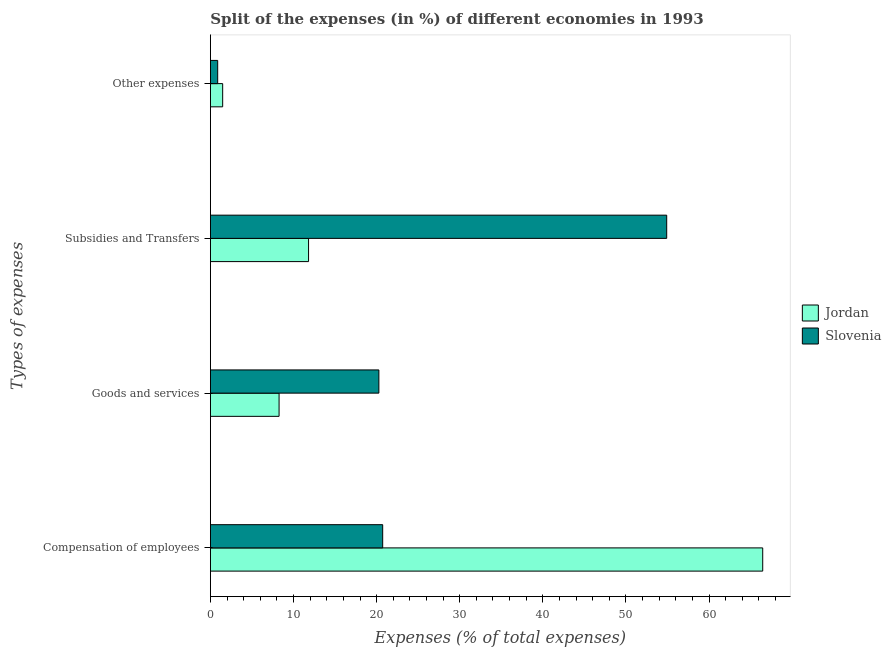Are the number of bars per tick equal to the number of legend labels?
Offer a very short reply. Yes. Are the number of bars on each tick of the Y-axis equal?
Provide a succinct answer. Yes. How many bars are there on the 3rd tick from the bottom?
Keep it short and to the point. 2. What is the label of the 3rd group of bars from the top?
Provide a succinct answer. Goods and services. What is the percentage of amount spent on other expenses in Jordan?
Your response must be concise. 1.48. Across all countries, what is the maximum percentage of amount spent on compensation of employees?
Your response must be concise. 66.45. Across all countries, what is the minimum percentage of amount spent on other expenses?
Provide a succinct answer. 0.88. In which country was the percentage of amount spent on subsidies maximum?
Ensure brevity in your answer.  Slovenia. In which country was the percentage of amount spent on compensation of employees minimum?
Offer a very short reply. Slovenia. What is the total percentage of amount spent on goods and services in the graph?
Your answer should be very brief. 28.53. What is the difference between the percentage of amount spent on goods and services in Slovenia and that in Jordan?
Make the answer very short. 12.01. What is the difference between the percentage of amount spent on subsidies in Jordan and the percentage of amount spent on other expenses in Slovenia?
Your answer should be compact. 10.93. What is the average percentage of amount spent on subsidies per country?
Your response must be concise. 33.35. What is the difference between the percentage of amount spent on other expenses and percentage of amount spent on compensation of employees in Jordan?
Provide a succinct answer. -64.97. What is the ratio of the percentage of amount spent on other expenses in Jordan to that in Slovenia?
Your answer should be very brief. 1.68. Is the difference between the percentage of amount spent on other expenses in Slovenia and Jordan greater than the difference between the percentage of amount spent on subsidies in Slovenia and Jordan?
Your response must be concise. No. What is the difference between the highest and the second highest percentage of amount spent on compensation of employees?
Make the answer very short. 45.72. What is the difference between the highest and the lowest percentage of amount spent on compensation of employees?
Provide a succinct answer. 45.72. In how many countries, is the percentage of amount spent on other expenses greater than the average percentage of amount spent on other expenses taken over all countries?
Make the answer very short. 1. Is the sum of the percentage of amount spent on subsidies in Jordan and Slovenia greater than the maximum percentage of amount spent on compensation of employees across all countries?
Provide a short and direct response. Yes. Is it the case that in every country, the sum of the percentage of amount spent on compensation of employees and percentage of amount spent on other expenses is greater than the sum of percentage of amount spent on goods and services and percentage of amount spent on subsidies?
Ensure brevity in your answer.  No. What does the 2nd bar from the top in Other expenses represents?
Your answer should be very brief. Jordan. What does the 2nd bar from the bottom in Other expenses represents?
Make the answer very short. Slovenia. Are all the bars in the graph horizontal?
Make the answer very short. Yes. How many countries are there in the graph?
Keep it short and to the point. 2. What is the difference between two consecutive major ticks on the X-axis?
Give a very brief answer. 10. Are the values on the major ticks of X-axis written in scientific E-notation?
Your answer should be very brief. No. Where does the legend appear in the graph?
Your answer should be compact. Center right. How many legend labels are there?
Provide a succinct answer. 2. How are the legend labels stacked?
Ensure brevity in your answer.  Vertical. What is the title of the graph?
Offer a very short reply. Split of the expenses (in %) of different economies in 1993. What is the label or title of the X-axis?
Provide a succinct answer. Expenses (% of total expenses). What is the label or title of the Y-axis?
Provide a succinct answer. Types of expenses. What is the Expenses (% of total expenses) of Jordan in Compensation of employees?
Your answer should be very brief. 66.45. What is the Expenses (% of total expenses) of Slovenia in Compensation of employees?
Provide a succinct answer. 20.73. What is the Expenses (% of total expenses) of Jordan in Goods and services?
Ensure brevity in your answer.  8.26. What is the Expenses (% of total expenses) of Slovenia in Goods and services?
Ensure brevity in your answer.  20.27. What is the Expenses (% of total expenses) of Jordan in Subsidies and Transfers?
Offer a very short reply. 11.81. What is the Expenses (% of total expenses) in Slovenia in Subsidies and Transfers?
Your answer should be very brief. 54.9. What is the Expenses (% of total expenses) in Jordan in Other expenses?
Offer a terse response. 1.48. What is the Expenses (% of total expenses) of Slovenia in Other expenses?
Your answer should be very brief. 0.88. Across all Types of expenses, what is the maximum Expenses (% of total expenses) in Jordan?
Provide a succinct answer. 66.45. Across all Types of expenses, what is the maximum Expenses (% of total expenses) in Slovenia?
Give a very brief answer. 54.9. Across all Types of expenses, what is the minimum Expenses (% of total expenses) of Jordan?
Give a very brief answer. 1.48. Across all Types of expenses, what is the minimum Expenses (% of total expenses) in Slovenia?
Offer a very short reply. 0.88. What is the total Expenses (% of total expenses) of Jordan in the graph?
Provide a succinct answer. 88. What is the total Expenses (% of total expenses) of Slovenia in the graph?
Your response must be concise. 96.78. What is the difference between the Expenses (% of total expenses) of Jordan in Compensation of employees and that in Goods and services?
Your answer should be compact. 58.19. What is the difference between the Expenses (% of total expenses) in Slovenia in Compensation of employees and that in Goods and services?
Provide a short and direct response. 0.46. What is the difference between the Expenses (% of total expenses) in Jordan in Compensation of employees and that in Subsidies and Transfers?
Your answer should be very brief. 54.64. What is the difference between the Expenses (% of total expenses) of Slovenia in Compensation of employees and that in Subsidies and Transfers?
Give a very brief answer. -34.17. What is the difference between the Expenses (% of total expenses) of Jordan in Compensation of employees and that in Other expenses?
Provide a short and direct response. 64.97. What is the difference between the Expenses (% of total expenses) in Slovenia in Compensation of employees and that in Other expenses?
Give a very brief answer. 19.85. What is the difference between the Expenses (% of total expenses) in Jordan in Goods and services and that in Subsidies and Transfers?
Provide a short and direct response. -3.55. What is the difference between the Expenses (% of total expenses) in Slovenia in Goods and services and that in Subsidies and Transfers?
Your answer should be compact. -34.63. What is the difference between the Expenses (% of total expenses) of Jordan in Goods and services and that in Other expenses?
Offer a terse response. 6.79. What is the difference between the Expenses (% of total expenses) in Slovenia in Goods and services and that in Other expenses?
Provide a short and direct response. 19.39. What is the difference between the Expenses (% of total expenses) of Jordan in Subsidies and Transfers and that in Other expenses?
Give a very brief answer. 10.33. What is the difference between the Expenses (% of total expenses) in Slovenia in Subsidies and Transfers and that in Other expenses?
Offer a terse response. 54.02. What is the difference between the Expenses (% of total expenses) in Jordan in Compensation of employees and the Expenses (% of total expenses) in Slovenia in Goods and services?
Your response must be concise. 46.18. What is the difference between the Expenses (% of total expenses) in Jordan in Compensation of employees and the Expenses (% of total expenses) in Slovenia in Subsidies and Transfers?
Ensure brevity in your answer.  11.55. What is the difference between the Expenses (% of total expenses) in Jordan in Compensation of employees and the Expenses (% of total expenses) in Slovenia in Other expenses?
Ensure brevity in your answer.  65.57. What is the difference between the Expenses (% of total expenses) in Jordan in Goods and services and the Expenses (% of total expenses) in Slovenia in Subsidies and Transfers?
Provide a succinct answer. -46.63. What is the difference between the Expenses (% of total expenses) of Jordan in Goods and services and the Expenses (% of total expenses) of Slovenia in Other expenses?
Ensure brevity in your answer.  7.38. What is the difference between the Expenses (% of total expenses) of Jordan in Subsidies and Transfers and the Expenses (% of total expenses) of Slovenia in Other expenses?
Offer a very short reply. 10.93. What is the average Expenses (% of total expenses) in Jordan per Types of expenses?
Make the answer very short. 22. What is the average Expenses (% of total expenses) of Slovenia per Types of expenses?
Offer a terse response. 24.19. What is the difference between the Expenses (% of total expenses) in Jordan and Expenses (% of total expenses) in Slovenia in Compensation of employees?
Make the answer very short. 45.72. What is the difference between the Expenses (% of total expenses) in Jordan and Expenses (% of total expenses) in Slovenia in Goods and services?
Keep it short and to the point. -12.01. What is the difference between the Expenses (% of total expenses) in Jordan and Expenses (% of total expenses) in Slovenia in Subsidies and Transfers?
Offer a very short reply. -43.09. What is the difference between the Expenses (% of total expenses) in Jordan and Expenses (% of total expenses) in Slovenia in Other expenses?
Keep it short and to the point. 0.6. What is the ratio of the Expenses (% of total expenses) in Jordan in Compensation of employees to that in Goods and services?
Your answer should be very brief. 8.04. What is the ratio of the Expenses (% of total expenses) in Slovenia in Compensation of employees to that in Goods and services?
Your answer should be compact. 1.02. What is the ratio of the Expenses (% of total expenses) in Jordan in Compensation of employees to that in Subsidies and Transfers?
Provide a short and direct response. 5.63. What is the ratio of the Expenses (% of total expenses) of Slovenia in Compensation of employees to that in Subsidies and Transfers?
Provide a short and direct response. 0.38. What is the ratio of the Expenses (% of total expenses) in Jordan in Compensation of employees to that in Other expenses?
Offer a very short reply. 44.95. What is the ratio of the Expenses (% of total expenses) of Slovenia in Compensation of employees to that in Other expenses?
Provide a succinct answer. 23.58. What is the ratio of the Expenses (% of total expenses) of Jordan in Goods and services to that in Subsidies and Transfers?
Keep it short and to the point. 0.7. What is the ratio of the Expenses (% of total expenses) of Slovenia in Goods and services to that in Subsidies and Transfers?
Your response must be concise. 0.37. What is the ratio of the Expenses (% of total expenses) of Jordan in Goods and services to that in Other expenses?
Your answer should be compact. 5.59. What is the ratio of the Expenses (% of total expenses) in Slovenia in Goods and services to that in Other expenses?
Keep it short and to the point. 23.06. What is the ratio of the Expenses (% of total expenses) of Jordan in Subsidies and Transfers to that in Other expenses?
Offer a very short reply. 7.99. What is the ratio of the Expenses (% of total expenses) in Slovenia in Subsidies and Transfers to that in Other expenses?
Provide a short and direct response. 62.46. What is the difference between the highest and the second highest Expenses (% of total expenses) of Jordan?
Make the answer very short. 54.64. What is the difference between the highest and the second highest Expenses (% of total expenses) of Slovenia?
Your response must be concise. 34.17. What is the difference between the highest and the lowest Expenses (% of total expenses) of Jordan?
Ensure brevity in your answer.  64.97. What is the difference between the highest and the lowest Expenses (% of total expenses) in Slovenia?
Provide a succinct answer. 54.02. 